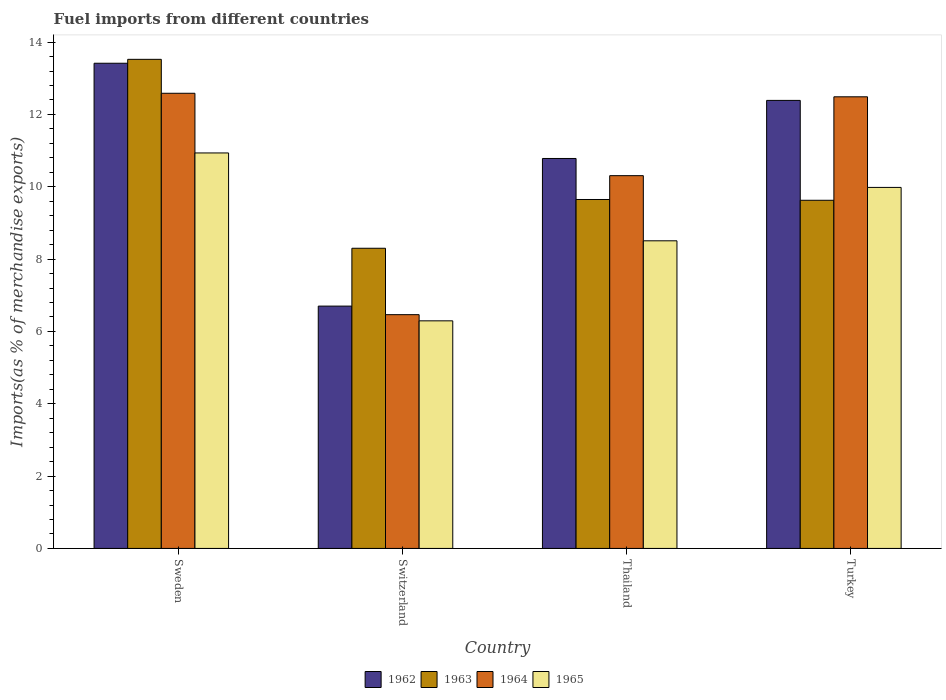Are the number of bars per tick equal to the number of legend labels?
Your answer should be very brief. Yes. How many bars are there on the 1st tick from the right?
Keep it short and to the point. 4. In how many cases, is the number of bars for a given country not equal to the number of legend labels?
Your response must be concise. 0. What is the percentage of imports to different countries in 1962 in Sweden?
Keep it short and to the point. 13.42. Across all countries, what is the maximum percentage of imports to different countries in 1964?
Offer a terse response. 12.58. Across all countries, what is the minimum percentage of imports to different countries in 1963?
Make the answer very short. 8.3. In which country was the percentage of imports to different countries in 1962 maximum?
Give a very brief answer. Sweden. In which country was the percentage of imports to different countries in 1963 minimum?
Offer a very short reply. Switzerland. What is the total percentage of imports to different countries in 1965 in the graph?
Your answer should be very brief. 35.72. What is the difference between the percentage of imports to different countries in 1962 in Thailand and that in Turkey?
Make the answer very short. -1.61. What is the difference between the percentage of imports to different countries in 1965 in Sweden and the percentage of imports to different countries in 1964 in Thailand?
Provide a succinct answer. 0.63. What is the average percentage of imports to different countries in 1964 per country?
Provide a short and direct response. 10.46. What is the difference between the percentage of imports to different countries of/in 1962 and percentage of imports to different countries of/in 1964 in Switzerland?
Your answer should be very brief. 0.24. In how many countries, is the percentage of imports to different countries in 1965 greater than 13.6 %?
Offer a very short reply. 0. What is the ratio of the percentage of imports to different countries in 1962 in Switzerland to that in Thailand?
Provide a short and direct response. 0.62. Is the percentage of imports to different countries in 1963 in Sweden less than that in Switzerland?
Your response must be concise. No. What is the difference between the highest and the second highest percentage of imports to different countries in 1962?
Offer a terse response. -1.61. What is the difference between the highest and the lowest percentage of imports to different countries in 1965?
Give a very brief answer. 4.64. In how many countries, is the percentage of imports to different countries in 1963 greater than the average percentage of imports to different countries in 1963 taken over all countries?
Give a very brief answer. 1. What does the 3rd bar from the right in Turkey represents?
Your answer should be compact. 1963. How many bars are there?
Your answer should be very brief. 16. Does the graph contain any zero values?
Provide a short and direct response. No. How many legend labels are there?
Provide a succinct answer. 4. What is the title of the graph?
Offer a very short reply. Fuel imports from different countries. What is the label or title of the Y-axis?
Ensure brevity in your answer.  Imports(as % of merchandise exports). What is the Imports(as % of merchandise exports) of 1962 in Sweden?
Provide a succinct answer. 13.42. What is the Imports(as % of merchandise exports) in 1963 in Sweden?
Ensure brevity in your answer.  13.52. What is the Imports(as % of merchandise exports) in 1964 in Sweden?
Provide a short and direct response. 12.58. What is the Imports(as % of merchandise exports) in 1965 in Sweden?
Make the answer very short. 10.93. What is the Imports(as % of merchandise exports) of 1962 in Switzerland?
Offer a very short reply. 6.7. What is the Imports(as % of merchandise exports) in 1963 in Switzerland?
Your response must be concise. 8.3. What is the Imports(as % of merchandise exports) of 1964 in Switzerland?
Your answer should be compact. 6.46. What is the Imports(as % of merchandise exports) in 1965 in Switzerland?
Your answer should be compact. 6.29. What is the Imports(as % of merchandise exports) in 1962 in Thailand?
Your answer should be very brief. 10.78. What is the Imports(as % of merchandise exports) in 1963 in Thailand?
Offer a very short reply. 9.65. What is the Imports(as % of merchandise exports) in 1964 in Thailand?
Provide a succinct answer. 10.31. What is the Imports(as % of merchandise exports) in 1965 in Thailand?
Offer a terse response. 8.51. What is the Imports(as % of merchandise exports) in 1962 in Turkey?
Your response must be concise. 12.39. What is the Imports(as % of merchandise exports) of 1963 in Turkey?
Ensure brevity in your answer.  9.63. What is the Imports(as % of merchandise exports) in 1964 in Turkey?
Ensure brevity in your answer.  12.49. What is the Imports(as % of merchandise exports) in 1965 in Turkey?
Offer a very short reply. 9.98. Across all countries, what is the maximum Imports(as % of merchandise exports) of 1962?
Your answer should be compact. 13.42. Across all countries, what is the maximum Imports(as % of merchandise exports) of 1963?
Ensure brevity in your answer.  13.52. Across all countries, what is the maximum Imports(as % of merchandise exports) in 1964?
Your response must be concise. 12.58. Across all countries, what is the maximum Imports(as % of merchandise exports) of 1965?
Ensure brevity in your answer.  10.93. Across all countries, what is the minimum Imports(as % of merchandise exports) in 1962?
Keep it short and to the point. 6.7. Across all countries, what is the minimum Imports(as % of merchandise exports) in 1963?
Ensure brevity in your answer.  8.3. Across all countries, what is the minimum Imports(as % of merchandise exports) in 1964?
Provide a short and direct response. 6.46. Across all countries, what is the minimum Imports(as % of merchandise exports) of 1965?
Offer a very short reply. 6.29. What is the total Imports(as % of merchandise exports) of 1962 in the graph?
Ensure brevity in your answer.  43.29. What is the total Imports(as % of merchandise exports) of 1963 in the graph?
Make the answer very short. 41.1. What is the total Imports(as % of merchandise exports) of 1964 in the graph?
Give a very brief answer. 41.84. What is the total Imports(as % of merchandise exports) in 1965 in the graph?
Give a very brief answer. 35.72. What is the difference between the Imports(as % of merchandise exports) in 1962 in Sweden and that in Switzerland?
Give a very brief answer. 6.72. What is the difference between the Imports(as % of merchandise exports) of 1963 in Sweden and that in Switzerland?
Your response must be concise. 5.22. What is the difference between the Imports(as % of merchandise exports) in 1964 in Sweden and that in Switzerland?
Keep it short and to the point. 6.12. What is the difference between the Imports(as % of merchandise exports) in 1965 in Sweden and that in Switzerland?
Provide a succinct answer. 4.64. What is the difference between the Imports(as % of merchandise exports) in 1962 in Sweden and that in Thailand?
Offer a very short reply. 2.63. What is the difference between the Imports(as % of merchandise exports) of 1963 in Sweden and that in Thailand?
Offer a very short reply. 3.88. What is the difference between the Imports(as % of merchandise exports) of 1964 in Sweden and that in Thailand?
Make the answer very short. 2.28. What is the difference between the Imports(as % of merchandise exports) in 1965 in Sweden and that in Thailand?
Provide a succinct answer. 2.43. What is the difference between the Imports(as % of merchandise exports) in 1962 in Sweden and that in Turkey?
Offer a terse response. 1.03. What is the difference between the Imports(as % of merchandise exports) of 1963 in Sweden and that in Turkey?
Offer a very short reply. 3.9. What is the difference between the Imports(as % of merchandise exports) in 1964 in Sweden and that in Turkey?
Give a very brief answer. 0.1. What is the difference between the Imports(as % of merchandise exports) in 1965 in Sweden and that in Turkey?
Offer a very short reply. 0.95. What is the difference between the Imports(as % of merchandise exports) of 1962 in Switzerland and that in Thailand?
Offer a very short reply. -4.08. What is the difference between the Imports(as % of merchandise exports) of 1963 in Switzerland and that in Thailand?
Keep it short and to the point. -1.35. What is the difference between the Imports(as % of merchandise exports) in 1964 in Switzerland and that in Thailand?
Offer a terse response. -3.84. What is the difference between the Imports(as % of merchandise exports) in 1965 in Switzerland and that in Thailand?
Your answer should be very brief. -2.21. What is the difference between the Imports(as % of merchandise exports) of 1962 in Switzerland and that in Turkey?
Provide a short and direct response. -5.69. What is the difference between the Imports(as % of merchandise exports) of 1963 in Switzerland and that in Turkey?
Your answer should be very brief. -1.33. What is the difference between the Imports(as % of merchandise exports) of 1964 in Switzerland and that in Turkey?
Ensure brevity in your answer.  -6.02. What is the difference between the Imports(as % of merchandise exports) in 1965 in Switzerland and that in Turkey?
Provide a succinct answer. -3.69. What is the difference between the Imports(as % of merchandise exports) in 1962 in Thailand and that in Turkey?
Keep it short and to the point. -1.61. What is the difference between the Imports(as % of merchandise exports) of 1963 in Thailand and that in Turkey?
Your response must be concise. 0.02. What is the difference between the Imports(as % of merchandise exports) of 1964 in Thailand and that in Turkey?
Make the answer very short. -2.18. What is the difference between the Imports(as % of merchandise exports) of 1965 in Thailand and that in Turkey?
Your answer should be very brief. -1.48. What is the difference between the Imports(as % of merchandise exports) of 1962 in Sweden and the Imports(as % of merchandise exports) of 1963 in Switzerland?
Make the answer very short. 5.12. What is the difference between the Imports(as % of merchandise exports) in 1962 in Sweden and the Imports(as % of merchandise exports) in 1964 in Switzerland?
Ensure brevity in your answer.  6.95. What is the difference between the Imports(as % of merchandise exports) of 1962 in Sweden and the Imports(as % of merchandise exports) of 1965 in Switzerland?
Offer a terse response. 7.12. What is the difference between the Imports(as % of merchandise exports) in 1963 in Sweden and the Imports(as % of merchandise exports) in 1964 in Switzerland?
Ensure brevity in your answer.  7.06. What is the difference between the Imports(as % of merchandise exports) of 1963 in Sweden and the Imports(as % of merchandise exports) of 1965 in Switzerland?
Offer a terse response. 7.23. What is the difference between the Imports(as % of merchandise exports) in 1964 in Sweden and the Imports(as % of merchandise exports) in 1965 in Switzerland?
Keep it short and to the point. 6.29. What is the difference between the Imports(as % of merchandise exports) of 1962 in Sweden and the Imports(as % of merchandise exports) of 1963 in Thailand?
Ensure brevity in your answer.  3.77. What is the difference between the Imports(as % of merchandise exports) of 1962 in Sweden and the Imports(as % of merchandise exports) of 1964 in Thailand?
Provide a succinct answer. 3.11. What is the difference between the Imports(as % of merchandise exports) in 1962 in Sweden and the Imports(as % of merchandise exports) in 1965 in Thailand?
Keep it short and to the point. 4.91. What is the difference between the Imports(as % of merchandise exports) in 1963 in Sweden and the Imports(as % of merchandise exports) in 1964 in Thailand?
Offer a terse response. 3.22. What is the difference between the Imports(as % of merchandise exports) in 1963 in Sweden and the Imports(as % of merchandise exports) in 1965 in Thailand?
Make the answer very short. 5.02. What is the difference between the Imports(as % of merchandise exports) of 1964 in Sweden and the Imports(as % of merchandise exports) of 1965 in Thailand?
Give a very brief answer. 4.08. What is the difference between the Imports(as % of merchandise exports) in 1962 in Sweden and the Imports(as % of merchandise exports) in 1963 in Turkey?
Offer a very short reply. 3.79. What is the difference between the Imports(as % of merchandise exports) in 1962 in Sweden and the Imports(as % of merchandise exports) in 1964 in Turkey?
Provide a succinct answer. 0.93. What is the difference between the Imports(as % of merchandise exports) of 1962 in Sweden and the Imports(as % of merchandise exports) of 1965 in Turkey?
Keep it short and to the point. 3.43. What is the difference between the Imports(as % of merchandise exports) in 1963 in Sweden and the Imports(as % of merchandise exports) in 1964 in Turkey?
Your answer should be very brief. 1.04. What is the difference between the Imports(as % of merchandise exports) in 1963 in Sweden and the Imports(as % of merchandise exports) in 1965 in Turkey?
Keep it short and to the point. 3.54. What is the difference between the Imports(as % of merchandise exports) in 1964 in Sweden and the Imports(as % of merchandise exports) in 1965 in Turkey?
Provide a succinct answer. 2.6. What is the difference between the Imports(as % of merchandise exports) of 1962 in Switzerland and the Imports(as % of merchandise exports) of 1963 in Thailand?
Keep it short and to the point. -2.95. What is the difference between the Imports(as % of merchandise exports) in 1962 in Switzerland and the Imports(as % of merchandise exports) in 1964 in Thailand?
Your answer should be compact. -3.61. What is the difference between the Imports(as % of merchandise exports) of 1962 in Switzerland and the Imports(as % of merchandise exports) of 1965 in Thailand?
Offer a very short reply. -1.81. What is the difference between the Imports(as % of merchandise exports) in 1963 in Switzerland and the Imports(as % of merchandise exports) in 1964 in Thailand?
Provide a short and direct response. -2.01. What is the difference between the Imports(as % of merchandise exports) in 1963 in Switzerland and the Imports(as % of merchandise exports) in 1965 in Thailand?
Keep it short and to the point. -0.21. What is the difference between the Imports(as % of merchandise exports) in 1964 in Switzerland and the Imports(as % of merchandise exports) in 1965 in Thailand?
Offer a terse response. -2.04. What is the difference between the Imports(as % of merchandise exports) of 1962 in Switzerland and the Imports(as % of merchandise exports) of 1963 in Turkey?
Provide a short and direct response. -2.93. What is the difference between the Imports(as % of merchandise exports) in 1962 in Switzerland and the Imports(as % of merchandise exports) in 1964 in Turkey?
Your answer should be very brief. -5.79. What is the difference between the Imports(as % of merchandise exports) of 1962 in Switzerland and the Imports(as % of merchandise exports) of 1965 in Turkey?
Offer a terse response. -3.28. What is the difference between the Imports(as % of merchandise exports) of 1963 in Switzerland and the Imports(as % of merchandise exports) of 1964 in Turkey?
Offer a very short reply. -4.19. What is the difference between the Imports(as % of merchandise exports) in 1963 in Switzerland and the Imports(as % of merchandise exports) in 1965 in Turkey?
Your answer should be compact. -1.68. What is the difference between the Imports(as % of merchandise exports) of 1964 in Switzerland and the Imports(as % of merchandise exports) of 1965 in Turkey?
Keep it short and to the point. -3.52. What is the difference between the Imports(as % of merchandise exports) of 1962 in Thailand and the Imports(as % of merchandise exports) of 1963 in Turkey?
Your response must be concise. 1.16. What is the difference between the Imports(as % of merchandise exports) of 1962 in Thailand and the Imports(as % of merchandise exports) of 1964 in Turkey?
Your response must be concise. -1.71. What is the difference between the Imports(as % of merchandise exports) of 1962 in Thailand and the Imports(as % of merchandise exports) of 1965 in Turkey?
Give a very brief answer. 0.8. What is the difference between the Imports(as % of merchandise exports) in 1963 in Thailand and the Imports(as % of merchandise exports) in 1964 in Turkey?
Your answer should be very brief. -2.84. What is the difference between the Imports(as % of merchandise exports) of 1963 in Thailand and the Imports(as % of merchandise exports) of 1965 in Turkey?
Offer a terse response. -0.33. What is the difference between the Imports(as % of merchandise exports) of 1964 in Thailand and the Imports(as % of merchandise exports) of 1965 in Turkey?
Ensure brevity in your answer.  0.32. What is the average Imports(as % of merchandise exports) of 1962 per country?
Your answer should be very brief. 10.82. What is the average Imports(as % of merchandise exports) of 1963 per country?
Offer a very short reply. 10.27. What is the average Imports(as % of merchandise exports) of 1964 per country?
Your answer should be compact. 10.46. What is the average Imports(as % of merchandise exports) of 1965 per country?
Keep it short and to the point. 8.93. What is the difference between the Imports(as % of merchandise exports) in 1962 and Imports(as % of merchandise exports) in 1963 in Sweden?
Offer a very short reply. -0.11. What is the difference between the Imports(as % of merchandise exports) of 1962 and Imports(as % of merchandise exports) of 1964 in Sweden?
Keep it short and to the point. 0.83. What is the difference between the Imports(as % of merchandise exports) of 1962 and Imports(as % of merchandise exports) of 1965 in Sweden?
Ensure brevity in your answer.  2.48. What is the difference between the Imports(as % of merchandise exports) in 1963 and Imports(as % of merchandise exports) in 1964 in Sweden?
Your response must be concise. 0.94. What is the difference between the Imports(as % of merchandise exports) in 1963 and Imports(as % of merchandise exports) in 1965 in Sweden?
Your response must be concise. 2.59. What is the difference between the Imports(as % of merchandise exports) of 1964 and Imports(as % of merchandise exports) of 1965 in Sweden?
Offer a terse response. 1.65. What is the difference between the Imports(as % of merchandise exports) of 1962 and Imports(as % of merchandise exports) of 1963 in Switzerland?
Your response must be concise. -1.6. What is the difference between the Imports(as % of merchandise exports) of 1962 and Imports(as % of merchandise exports) of 1964 in Switzerland?
Keep it short and to the point. 0.24. What is the difference between the Imports(as % of merchandise exports) in 1962 and Imports(as % of merchandise exports) in 1965 in Switzerland?
Provide a succinct answer. 0.41. What is the difference between the Imports(as % of merchandise exports) of 1963 and Imports(as % of merchandise exports) of 1964 in Switzerland?
Offer a very short reply. 1.84. What is the difference between the Imports(as % of merchandise exports) of 1963 and Imports(as % of merchandise exports) of 1965 in Switzerland?
Your response must be concise. 2.01. What is the difference between the Imports(as % of merchandise exports) of 1964 and Imports(as % of merchandise exports) of 1965 in Switzerland?
Make the answer very short. 0.17. What is the difference between the Imports(as % of merchandise exports) of 1962 and Imports(as % of merchandise exports) of 1963 in Thailand?
Your response must be concise. 1.13. What is the difference between the Imports(as % of merchandise exports) of 1962 and Imports(as % of merchandise exports) of 1964 in Thailand?
Offer a very short reply. 0.48. What is the difference between the Imports(as % of merchandise exports) in 1962 and Imports(as % of merchandise exports) in 1965 in Thailand?
Ensure brevity in your answer.  2.28. What is the difference between the Imports(as % of merchandise exports) in 1963 and Imports(as % of merchandise exports) in 1964 in Thailand?
Offer a terse response. -0.66. What is the difference between the Imports(as % of merchandise exports) in 1963 and Imports(as % of merchandise exports) in 1965 in Thailand?
Provide a succinct answer. 1.14. What is the difference between the Imports(as % of merchandise exports) in 1964 and Imports(as % of merchandise exports) in 1965 in Thailand?
Offer a terse response. 1.8. What is the difference between the Imports(as % of merchandise exports) in 1962 and Imports(as % of merchandise exports) in 1963 in Turkey?
Keep it short and to the point. 2.76. What is the difference between the Imports(as % of merchandise exports) of 1962 and Imports(as % of merchandise exports) of 1964 in Turkey?
Offer a terse response. -0.1. What is the difference between the Imports(as % of merchandise exports) in 1962 and Imports(as % of merchandise exports) in 1965 in Turkey?
Keep it short and to the point. 2.41. What is the difference between the Imports(as % of merchandise exports) of 1963 and Imports(as % of merchandise exports) of 1964 in Turkey?
Provide a succinct answer. -2.86. What is the difference between the Imports(as % of merchandise exports) of 1963 and Imports(as % of merchandise exports) of 1965 in Turkey?
Offer a very short reply. -0.36. What is the difference between the Imports(as % of merchandise exports) of 1964 and Imports(as % of merchandise exports) of 1965 in Turkey?
Ensure brevity in your answer.  2.51. What is the ratio of the Imports(as % of merchandise exports) in 1962 in Sweden to that in Switzerland?
Provide a short and direct response. 2. What is the ratio of the Imports(as % of merchandise exports) in 1963 in Sweden to that in Switzerland?
Your answer should be compact. 1.63. What is the ratio of the Imports(as % of merchandise exports) in 1964 in Sweden to that in Switzerland?
Give a very brief answer. 1.95. What is the ratio of the Imports(as % of merchandise exports) of 1965 in Sweden to that in Switzerland?
Your answer should be very brief. 1.74. What is the ratio of the Imports(as % of merchandise exports) of 1962 in Sweden to that in Thailand?
Offer a very short reply. 1.24. What is the ratio of the Imports(as % of merchandise exports) in 1963 in Sweden to that in Thailand?
Your answer should be very brief. 1.4. What is the ratio of the Imports(as % of merchandise exports) of 1964 in Sweden to that in Thailand?
Give a very brief answer. 1.22. What is the ratio of the Imports(as % of merchandise exports) of 1965 in Sweden to that in Thailand?
Provide a short and direct response. 1.29. What is the ratio of the Imports(as % of merchandise exports) of 1962 in Sweden to that in Turkey?
Your answer should be compact. 1.08. What is the ratio of the Imports(as % of merchandise exports) of 1963 in Sweden to that in Turkey?
Your answer should be compact. 1.4. What is the ratio of the Imports(as % of merchandise exports) in 1964 in Sweden to that in Turkey?
Your answer should be compact. 1.01. What is the ratio of the Imports(as % of merchandise exports) of 1965 in Sweden to that in Turkey?
Provide a succinct answer. 1.1. What is the ratio of the Imports(as % of merchandise exports) of 1962 in Switzerland to that in Thailand?
Your answer should be very brief. 0.62. What is the ratio of the Imports(as % of merchandise exports) of 1963 in Switzerland to that in Thailand?
Provide a short and direct response. 0.86. What is the ratio of the Imports(as % of merchandise exports) of 1964 in Switzerland to that in Thailand?
Ensure brevity in your answer.  0.63. What is the ratio of the Imports(as % of merchandise exports) of 1965 in Switzerland to that in Thailand?
Offer a terse response. 0.74. What is the ratio of the Imports(as % of merchandise exports) of 1962 in Switzerland to that in Turkey?
Your response must be concise. 0.54. What is the ratio of the Imports(as % of merchandise exports) of 1963 in Switzerland to that in Turkey?
Offer a very short reply. 0.86. What is the ratio of the Imports(as % of merchandise exports) of 1964 in Switzerland to that in Turkey?
Your answer should be compact. 0.52. What is the ratio of the Imports(as % of merchandise exports) in 1965 in Switzerland to that in Turkey?
Give a very brief answer. 0.63. What is the ratio of the Imports(as % of merchandise exports) of 1962 in Thailand to that in Turkey?
Give a very brief answer. 0.87. What is the ratio of the Imports(as % of merchandise exports) in 1964 in Thailand to that in Turkey?
Provide a short and direct response. 0.83. What is the ratio of the Imports(as % of merchandise exports) of 1965 in Thailand to that in Turkey?
Ensure brevity in your answer.  0.85. What is the difference between the highest and the second highest Imports(as % of merchandise exports) in 1962?
Your response must be concise. 1.03. What is the difference between the highest and the second highest Imports(as % of merchandise exports) in 1963?
Offer a terse response. 3.88. What is the difference between the highest and the second highest Imports(as % of merchandise exports) of 1964?
Offer a very short reply. 0.1. What is the difference between the highest and the second highest Imports(as % of merchandise exports) in 1965?
Your response must be concise. 0.95. What is the difference between the highest and the lowest Imports(as % of merchandise exports) of 1962?
Provide a succinct answer. 6.72. What is the difference between the highest and the lowest Imports(as % of merchandise exports) of 1963?
Your answer should be very brief. 5.22. What is the difference between the highest and the lowest Imports(as % of merchandise exports) in 1964?
Your response must be concise. 6.12. What is the difference between the highest and the lowest Imports(as % of merchandise exports) of 1965?
Offer a very short reply. 4.64. 